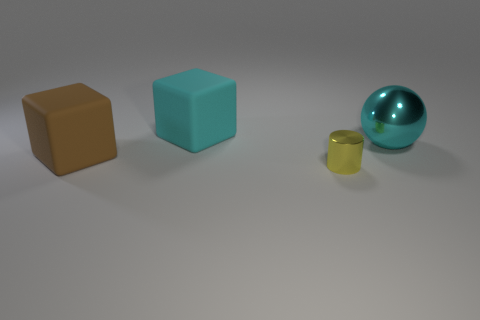Add 3 large cyan matte cubes. How many objects exist? 7 Subtract 1 blocks. How many blocks are left? 1 Subtract all balls. How many objects are left? 3 Subtract all cyan cylinders. How many cyan cubes are left? 1 Subtract all yellow things. Subtract all large blocks. How many objects are left? 1 Add 4 cyan things. How many cyan things are left? 6 Add 4 yellow cylinders. How many yellow cylinders exist? 5 Subtract 1 yellow cylinders. How many objects are left? 3 Subtract all purple cubes. Subtract all blue spheres. How many cubes are left? 2 